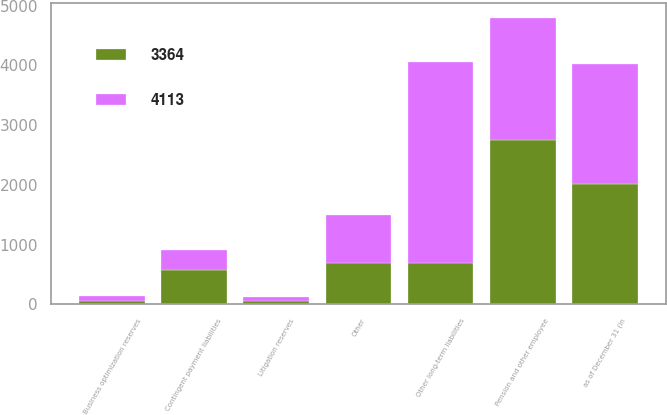Convert chart to OTSL. <chart><loc_0><loc_0><loc_500><loc_500><stacked_bar_chart><ecel><fcel>as of December 31 (in<fcel>Pension and other employee<fcel>Litigation reserves<fcel>Business optimization reserves<fcel>Contingent payment liabilities<fcel>Other<fcel>Other long-term liabilities<nl><fcel>3364<fcel>2014<fcel>2748<fcel>53<fcel>51<fcel>569<fcel>692<fcel>692<nl><fcel>4113<fcel>2013<fcel>2049<fcel>72<fcel>89<fcel>340<fcel>795<fcel>3364<nl></chart> 